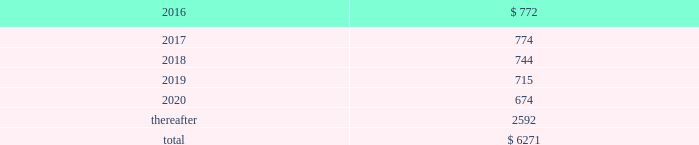Table of contents the company uses some custom components that are not commonly used by its competitors , and new products introduced by the company often utilize custom components available from only one source .
When a component or product uses new technologies , initial capacity constraints may exist until the suppliers 2019 yields have matured or manufacturing capacity has increased .
If the company 2019s supply of components for a new or existing product were delayed or constrained , or if an outsourcing partner delayed shipments of completed products to the company , the company 2019s financial condition and operating results could be materially adversely affected .
The company 2019s business and financial performance could also be materially adversely affected depending on the time required to obtain sufficient quantities from the original source , or to identify and obtain sufficient quantities from an alternative source .
Continued availability of these components at acceptable prices , or at all , may be affected if those suppliers concentrated on the production of common components instead of components customized to meet the company 2019s requirements .
The company has entered into agreements for the supply of many components ; however , there can be no guarantee that the company will be able to extend or renew these agreements on similar terms , or at all .
Therefore , the company remains subject to significant risks of supply shortages and price increases that could materially adversely affect its financial condition and operating results .
Substantially all of the company 2019s hardware products are manufactured by outsourcing partners that are located primarily in asia .
A significant concentration of this manufacturing is currently performed by a small number of outsourcing partners , often in single locations .
Certain of these outsourcing partners are the sole- sourced suppliers of components and manufacturers for many of the company 2019s products .
Although the company works closely with its outsourcing partners on manufacturing schedules , the company 2019s operating results could be adversely affected if its outsourcing partners were unable to meet their production commitments .
The company 2019s purchase commitments typically cover its requirements for periods up to 150 days .
Other off-balance sheet commitments operating leases the company leases various equipment and facilities , including retail space , under noncancelable operating lease arrangements .
The company does not currently utilize any other off-balance sheet financing arrangements .
The major facility leases are typically for terms not exceeding 10 years and generally contain multi-year renewal options .
As of september 26 , 2015 , the company had a total of 463 retail stores .
Leases for retail space are for terms ranging from five to 20 years , the majority of which are for 10 years , and often contain multi-year renewal options .
As of september 26 , 2015 , the company 2019s total future minimum lease payments under noncancelable operating leases were $ 6.3 billion , of which $ 3.6 billion related to leases for retail space .
Rent expense under all operating leases , including both cancelable and noncancelable leases , was $ 794 million , $ 717 million and $ 645 million in 2015 , 2014 and 2013 , respectively .
Future minimum lease payments under noncancelable operating leases having remaining terms in excess of one year as of september 26 , 2015 , are as follows ( in millions ) : .
Other commitments the company utilizes several outsourcing partners to manufacture sub-assemblies for the company 2019s products and to perform final assembly and testing of finished products .
These outsourcing partners acquire components and build product based on demand information supplied by the company , which typically covers periods up to 150 days .
The company also obtains individual components for its products from a wide variety of individual suppliers .
Consistent with industry practice , the company acquires components through a combination of purchase orders , supplier contracts and open orders based on projected demand information .
Where appropriate , the purchases are applied to inventory component prepayments that are outstanding with the respective supplier .
As of september 26 , 2015 , the company had outstanding off-balance sheet third-party manufacturing commitments and component purchase commitments of $ 29.5 billion .
Apple inc .
| 2015 form 10-k | 65 .
What was total rent expense under all operating leases , including both cancelable and noncancelable leases , in millions , in 2015 , 2014 and 2013? 
Computations: ((794 + 717) + 645)
Answer: 2156.0. 